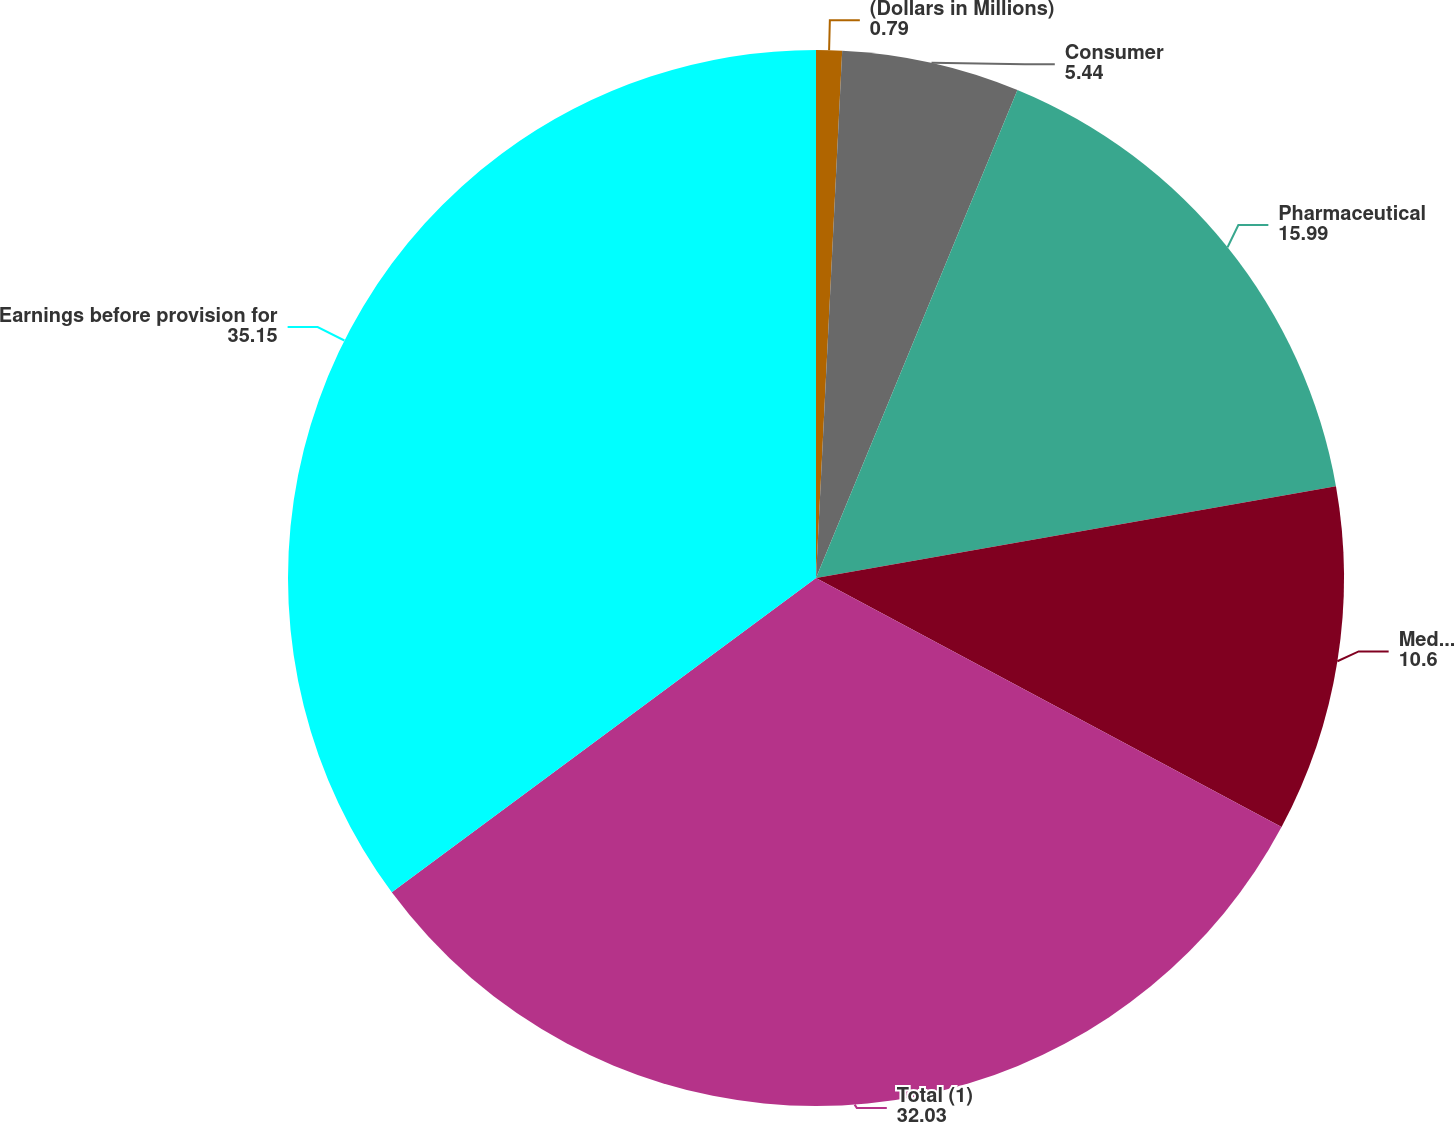Convert chart to OTSL. <chart><loc_0><loc_0><loc_500><loc_500><pie_chart><fcel>(Dollars in Millions)<fcel>Consumer<fcel>Pharmaceutical<fcel>Medical Devices<fcel>Total (1)<fcel>Earnings before provision for<nl><fcel>0.79%<fcel>5.44%<fcel>15.99%<fcel>10.6%<fcel>32.03%<fcel>35.15%<nl></chart> 